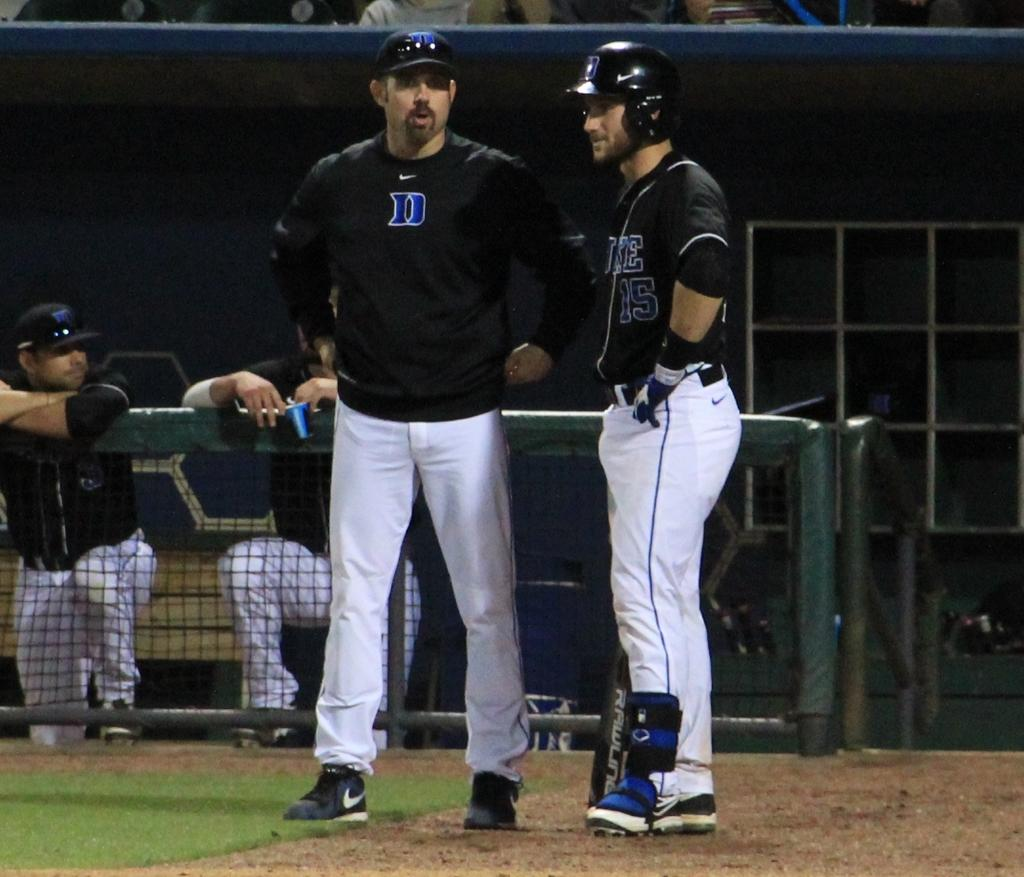<image>
Write a terse but informative summary of the picture. A player for the Duke University baseball team chats with his coach before batting. 